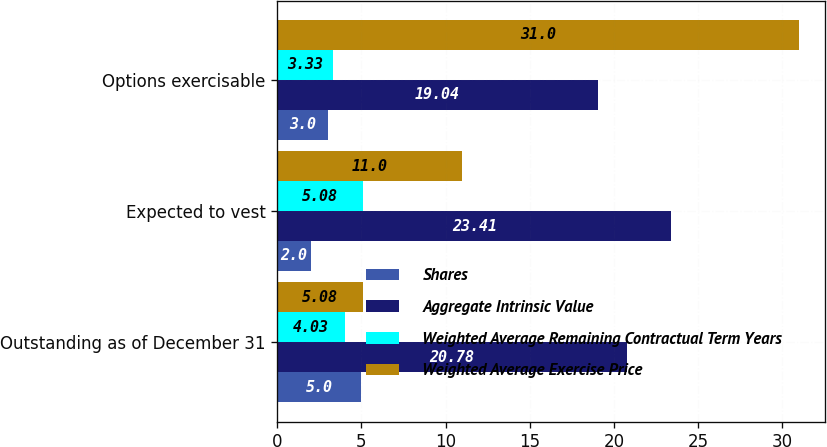Convert chart to OTSL. <chart><loc_0><loc_0><loc_500><loc_500><stacked_bar_chart><ecel><fcel>Outstanding as of December 31<fcel>Expected to vest<fcel>Options exercisable<nl><fcel>Shares<fcel>5<fcel>2<fcel>3<nl><fcel>Aggregate Intrinsic Value<fcel>20.78<fcel>23.41<fcel>19.04<nl><fcel>Weighted Average Remaining Contractual Term Years<fcel>4.03<fcel>5.08<fcel>3.33<nl><fcel>Weighted Average Exercise Price<fcel>5.08<fcel>11<fcel>31<nl></chart> 